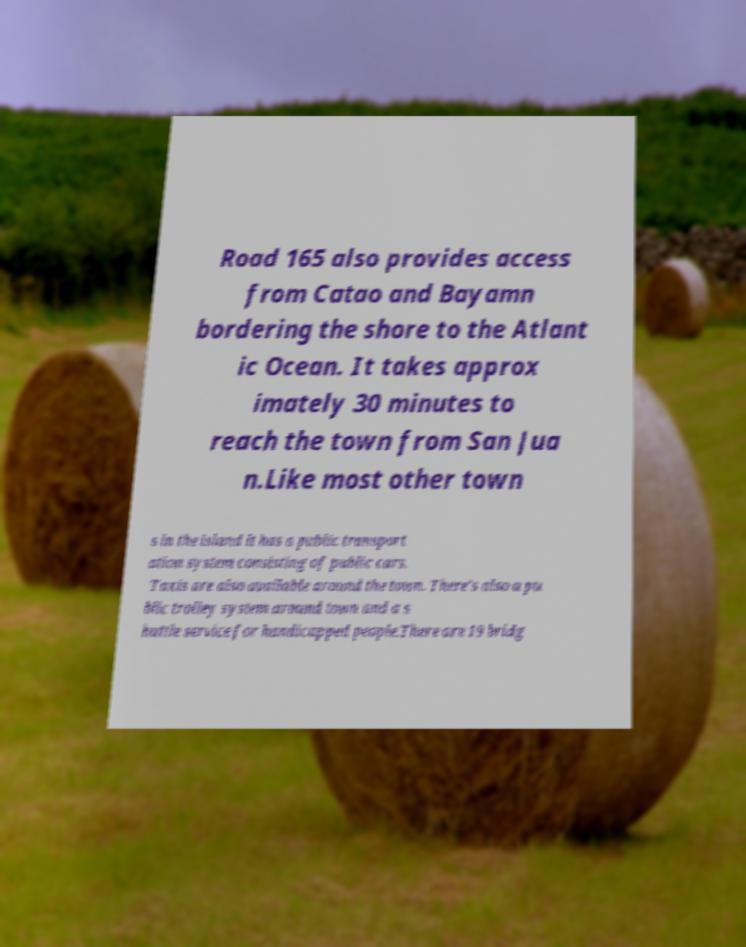Please read and relay the text visible in this image. What does it say? Road 165 also provides access from Catao and Bayamn bordering the shore to the Atlant ic Ocean. It takes approx imately 30 minutes to reach the town from San Jua n.Like most other town s in the island it has a public transport ation system consisting of public cars. Taxis are also available around the town. There's also a pu blic trolley system around town and a s huttle service for handicapped people.There are 19 bridg 